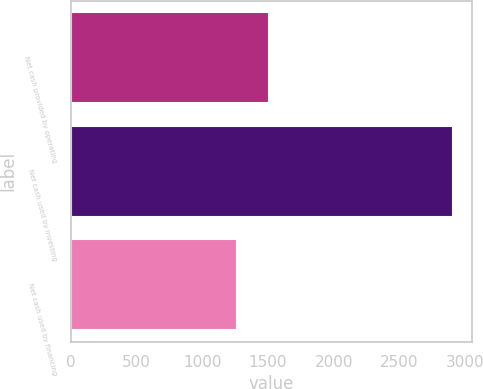Convert chart. <chart><loc_0><loc_0><loc_500><loc_500><bar_chart><fcel>Net cash provided by operating<fcel>Net cash used by investing<fcel>Net cash used by financing<nl><fcel>1510<fcel>2903<fcel>1265<nl></chart> 